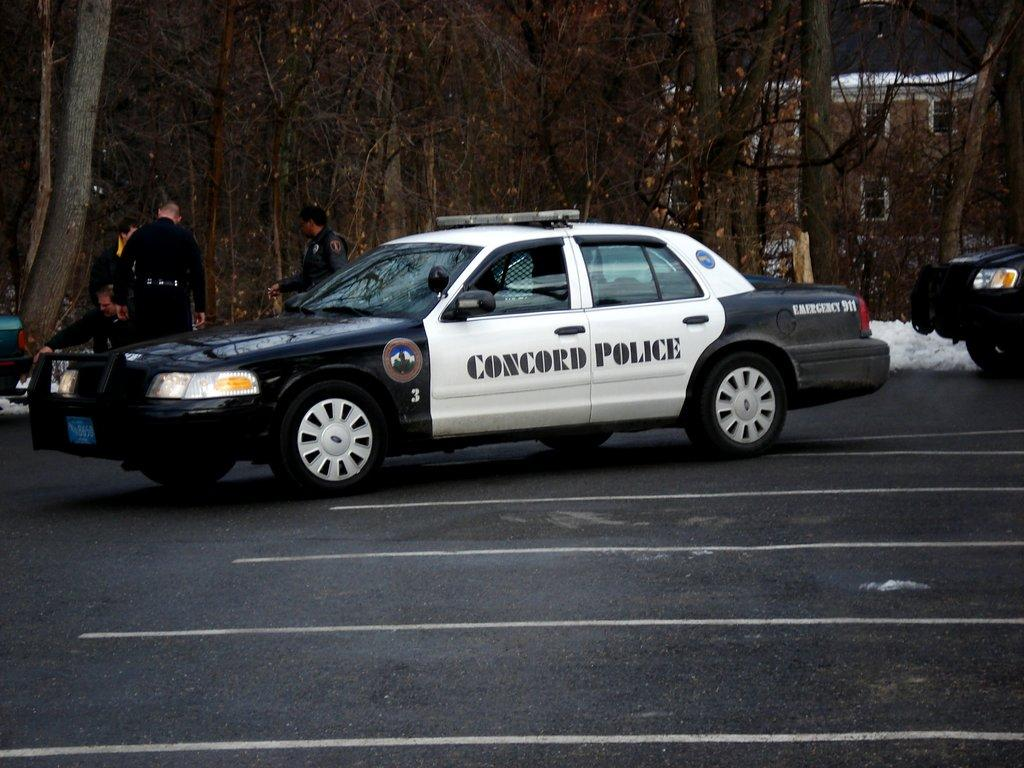How many cars are visible on the road in the image? There are two cars on the road in the image. What are the people on the other side of the road doing? The provided facts do not specify what the people are doing. What can be seen in the background of the image? There are trees and a building in the background of the image. What type of quiver can be seen on the cars in the image? There is no quiver present on the cars in the image. Can you tell me how many horns are visible on the people standing on the other side of the road? There are no horns visible on the people standing on the other side of the road in the image. 